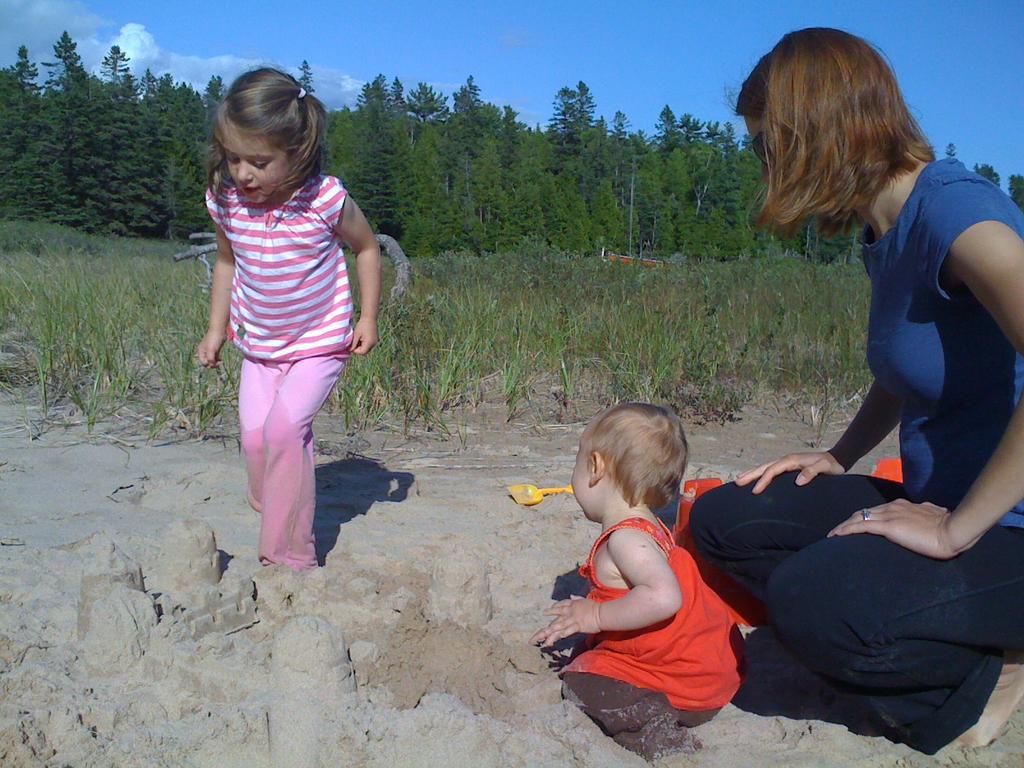Please provide a concise description of this image. In this image there is a girl and a toddler playing in the sand, behind the toddler there is a woman, beside them there are some objects and there is grass and metal pipes, behind that there are trees, at the top of the image there are clouds in the sky. 